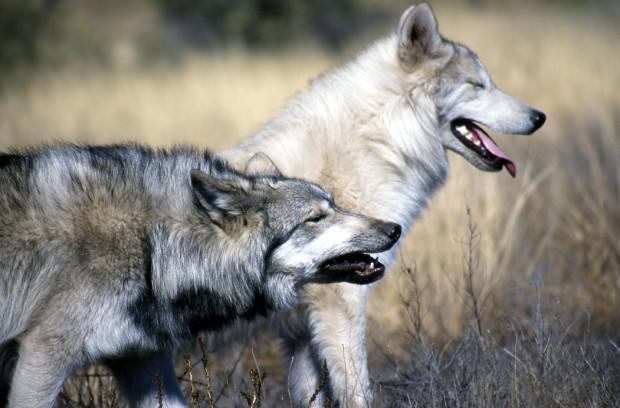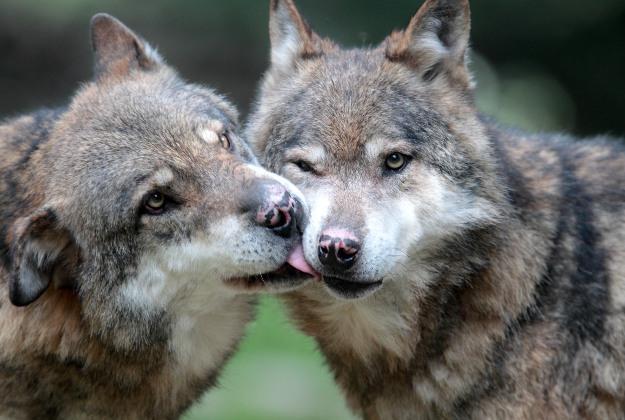The first image is the image on the left, the second image is the image on the right. For the images displayed, is the sentence "The left image shows exactly two wolves, at least one with its mouth open and at least one with its eyes shut." factually correct? Answer yes or no. Yes. The first image is the image on the left, the second image is the image on the right. Evaluate the accuracy of this statement regarding the images: "There are exactly four wolves in total.". Is it true? Answer yes or no. Yes. 